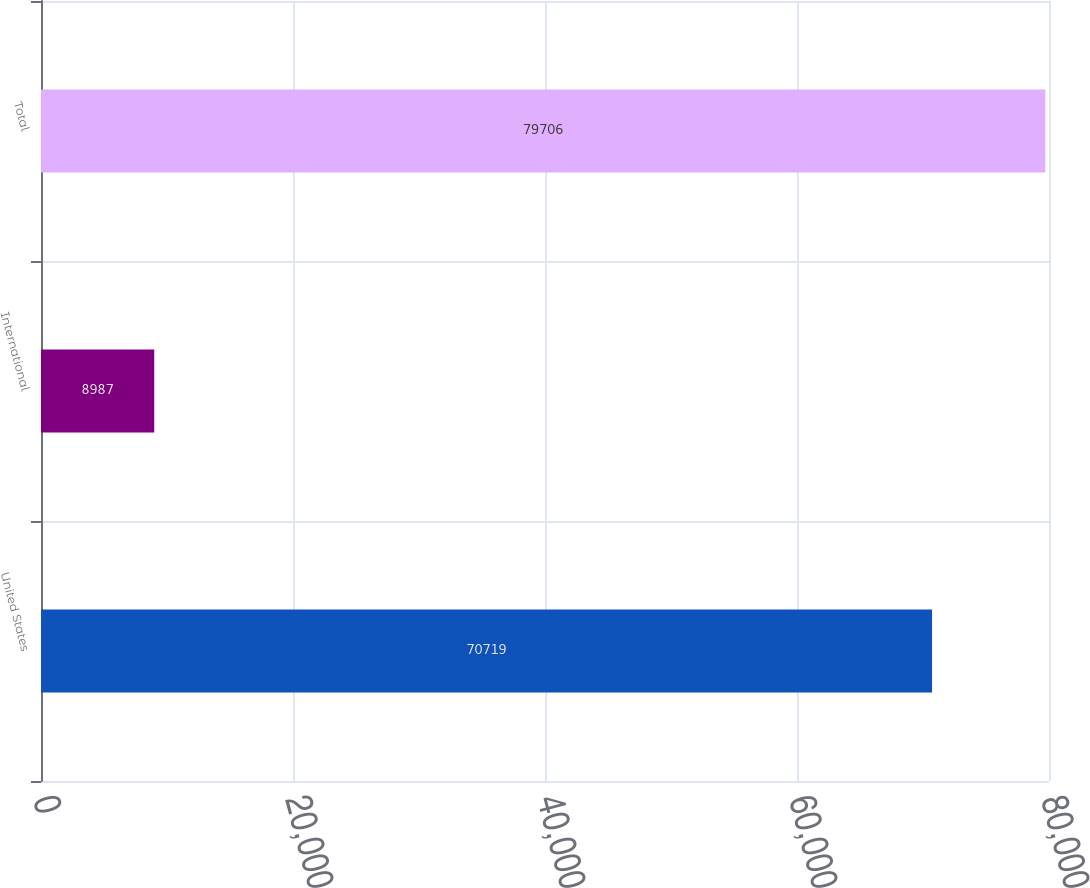Convert chart to OTSL. <chart><loc_0><loc_0><loc_500><loc_500><bar_chart><fcel>United States<fcel>International<fcel>Total<nl><fcel>70719<fcel>8987<fcel>79706<nl></chart> 